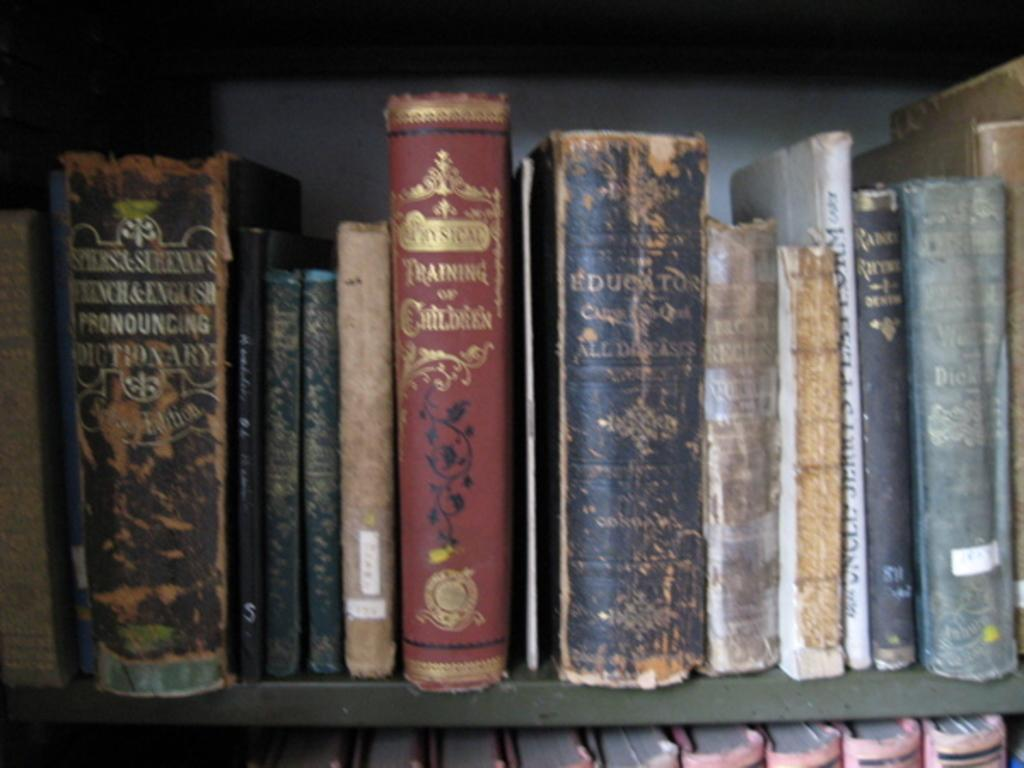What is the main subject of the image? The main subject of the image is a group of books. How are the books arranged in the image? The books are placed in shelves. What type of turkey can be seen in the image? There is no turkey present in the image; it features a group of books placed in shelves. What type of hospital is visible in the image? There is no hospital present in the image; it features a group of books placed in shelves. 